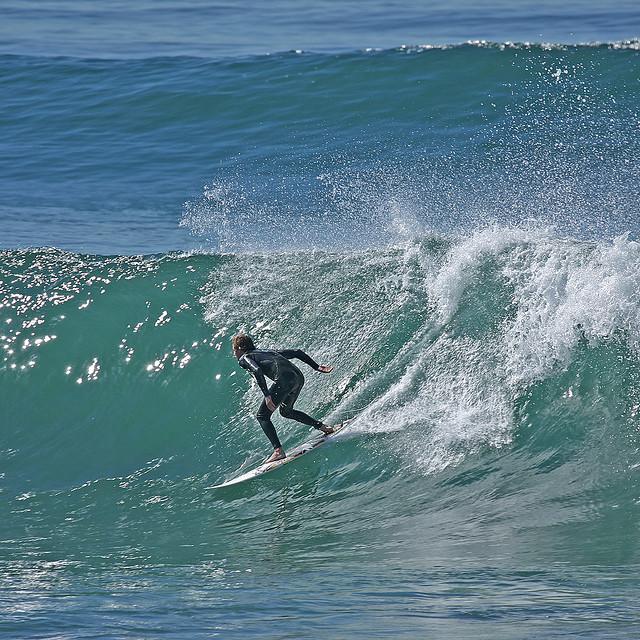Is this a professional surfer?
Concise answer only. Yes. How experienced is this surfer?
Short answer required. Very. Is the surfer in trouble?
Quick response, please. No. How many people are surfing?
Quick response, please. 1. Is it day time?
Concise answer only. Yes. What color is the water?
Answer briefly. Blue. Is the sea blue?
Keep it brief. Yes. Does this ocean stretch on into infinity?
Short answer required. Yes. Is this person a professional surf boarder?
Quick response, please. Yes. 